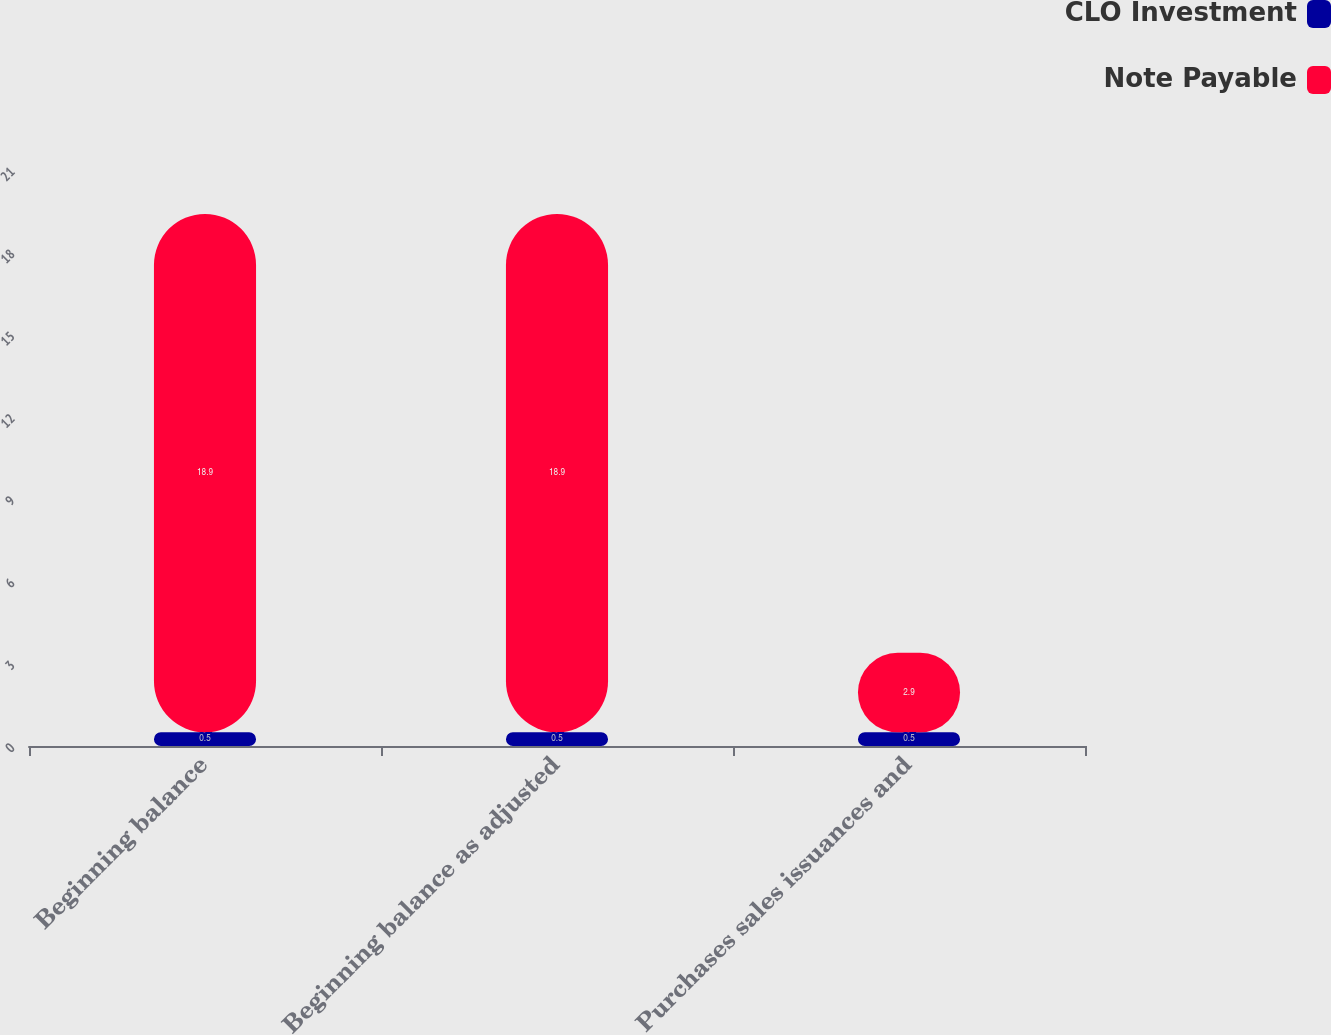Convert chart to OTSL. <chart><loc_0><loc_0><loc_500><loc_500><stacked_bar_chart><ecel><fcel>Beginning balance<fcel>Beginning balance as adjusted<fcel>Purchases sales issuances and<nl><fcel>CLO Investment<fcel>0.5<fcel>0.5<fcel>0.5<nl><fcel>Note Payable<fcel>18.9<fcel>18.9<fcel>2.9<nl></chart> 